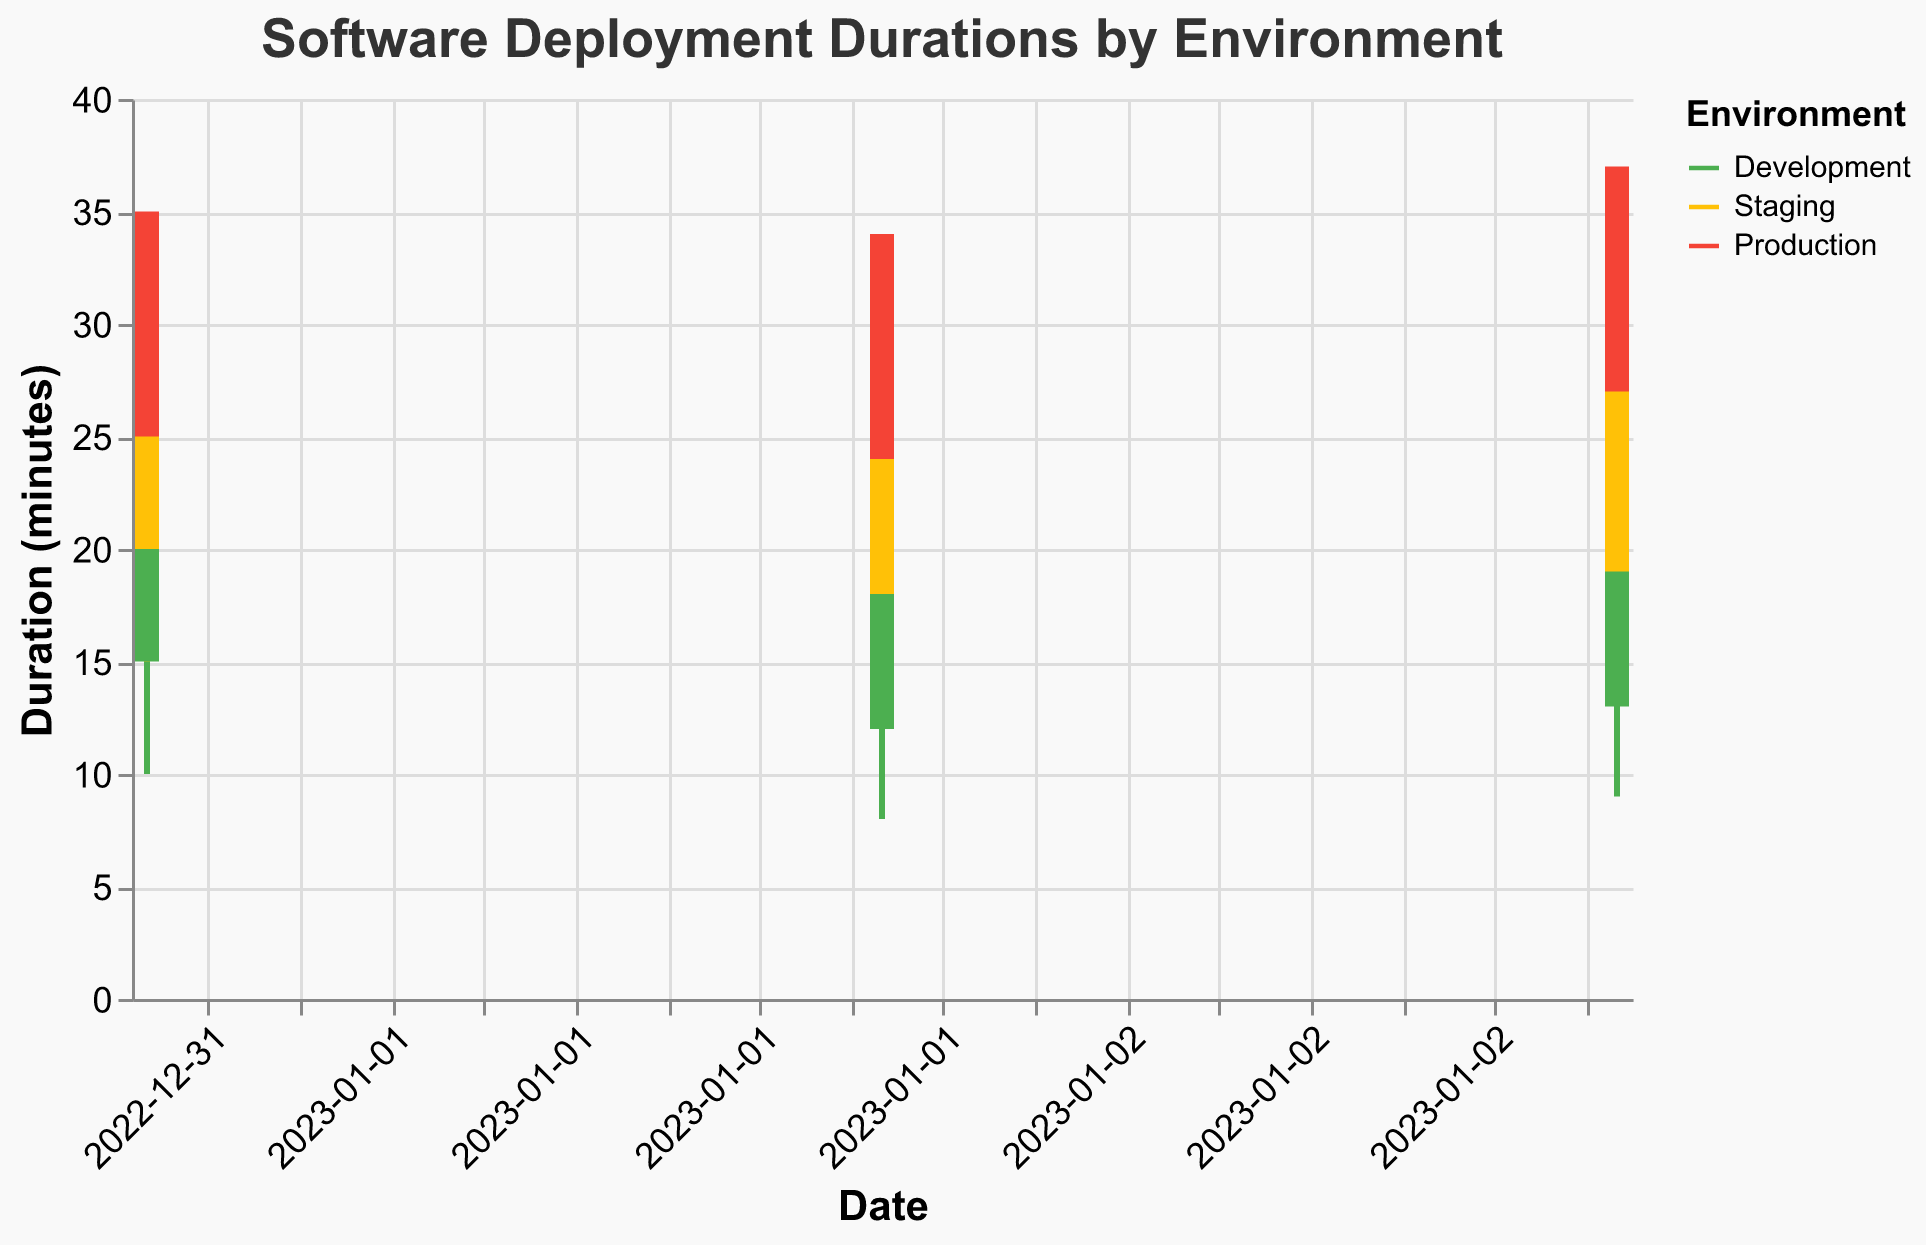Which environment has the highest average deployment duration for January 1, 2023? To calculate the average deployment duration, first add the "Start Duration (min)" and "End Duration (min)" for each environment on January 1, 2023, and then divide by 2. For Development: (10 + 20) / 2 = 15 minutes. For Staging: (15 + 25) / 2 = 20 minutes. For Production: (20 + 30) / 2 = 25 minutes. Production has the highest average deployment duration.
Answer: Production How does the maximum deployment duration on January 3, 2023, compare between Development and Production environments? Compare the "Max Duration (min)" values for both environments on January 3, 2023. Development has 23 minutes, while Production has 37 minutes.
Answer: Production has a higher maximum deployment duration Which environment shows the smallest range in deployment durations on January 2, 2023? Calculate the range by subtracting the "Min Duration (min)" from the "Max Duration (min)" for each environment on January 2, 2023: Development: 22 - 12 = 10 minutes, Staging: 28 - 18 = 10 minutes, Production: 34 - 24 = 10 minutes. All environments show the same range.
Answer: All environments have the same range What is the trend in "Start Duration (min)" for Development environment from January 1 to January 3, 2023? Observe the "Start Duration (min)" values for the Development environment over the given dates: January 1: 10 minutes, January 2: 8 minutes, January 3: 9 minutes. The trend shows a slight decrease from January 1 to January 2 and then a small increase by January 3.
Answer: Decreasing, then increasing On which date does the Staging environment have the highest variance in deployment durations? For each date, calculate the variance by finding the difference between "Max Duration (min)" and "Min Duration (min)" for Staging: January 1: 30 - 20 = 10 minutes, January 2: 28 - 18 = 10 minutes, January 3: 29 - 19 = 10 minutes. As the variance is the same, there is no single date with the highest variance.
Answer: All have the same variance What is the "End Duration (min)" for Production on January 2, 2023? Check the data provided specifically for Production on January 2, 2023. The "End Duration (min)" is 29 minutes.
Answer: 29 minutes Compare the deployment duration ranges for January 1, 2023, across all environments. Which environment has the widest range? Calculate the range for each environment on January 1, 2023: Development: 25 - 15 = 10 minutes, Staging: 30 - 20 = 10 minutes, Production: 35 - 25 = 10 minutes. All environments have the same range.
Answer: All environments have the same range In which environment did the longest single deployment duration occur, and what was the duration? Identify the highest "Max Duration (min)" across all environments. Production on January 3, 2023, has the longest duration at 37 minutes.
Answer: Production, 37 minutes 